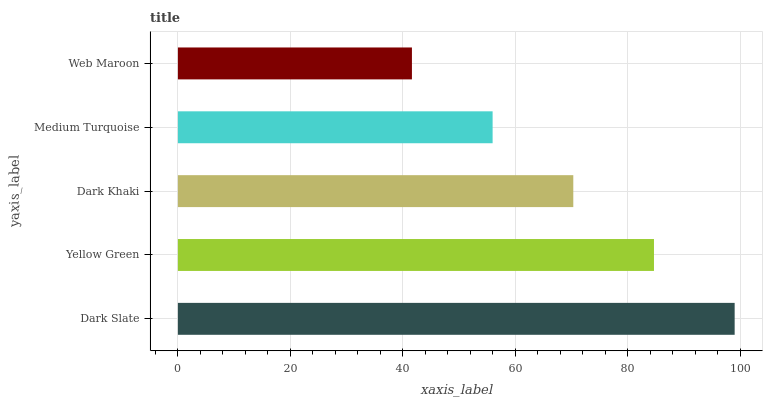Is Web Maroon the minimum?
Answer yes or no. Yes. Is Dark Slate the maximum?
Answer yes or no. Yes. Is Yellow Green the minimum?
Answer yes or no. No. Is Yellow Green the maximum?
Answer yes or no. No. Is Dark Slate greater than Yellow Green?
Answer yes or no. Yes. Is Yellow Green less than Dark Slate?
Answer yes or no. Yes. Is Yellow Green greater than Dark Slate?
Answer yes or no. No. Is Dark Slate less than Yellow Green?
Answer yes or no. No. Is Dark Khaki the high median?
Answer yes or no. Yes. Is Dark Khaki the low median?
Answer yes or no. Yes. Is Dark Slate the high median?
Answer yes or no. No. Is Yellow Green the low median?
Answer yes or no. No. 